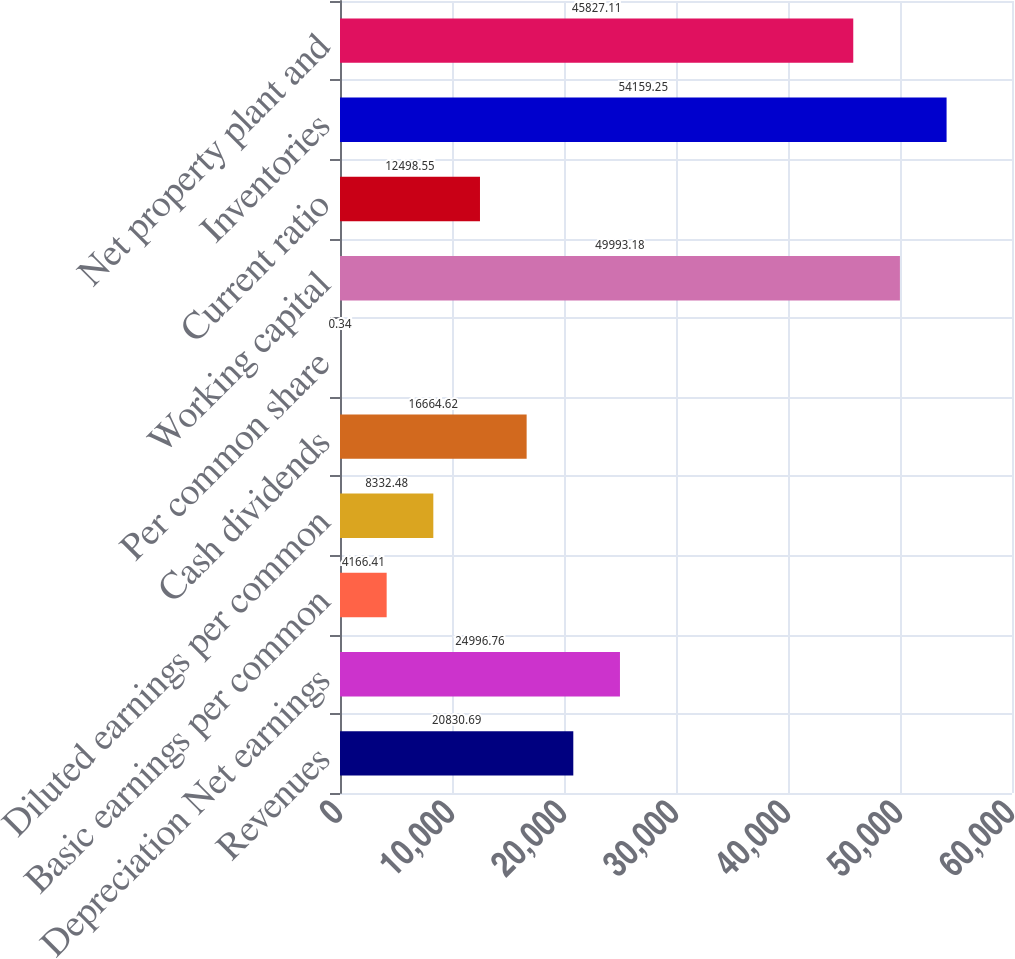Convert chart to OTSL. <chart><loc_0><loc_0><loc_500><loc_500><bar_chart><fcel>Revenues<fcel>Depreciation Net earnings<fcel>Basic earnings per common<fcel>Diluted earnings per common<fcel>Cash dividends<fcel>Per common share<fcel>Working capital<fcel>Current ratio<fcel>Inventories<fcel>Net property plant and<nl><fcel>20830.7<fcel>24996.8<fcel>4166.41<fcel>8332.48<fcel>16664.6<fcel>0.34<fcel>49993.2<fcel>12498.5<fcel>54159.2<fcel>45827.1<nl></chart> 